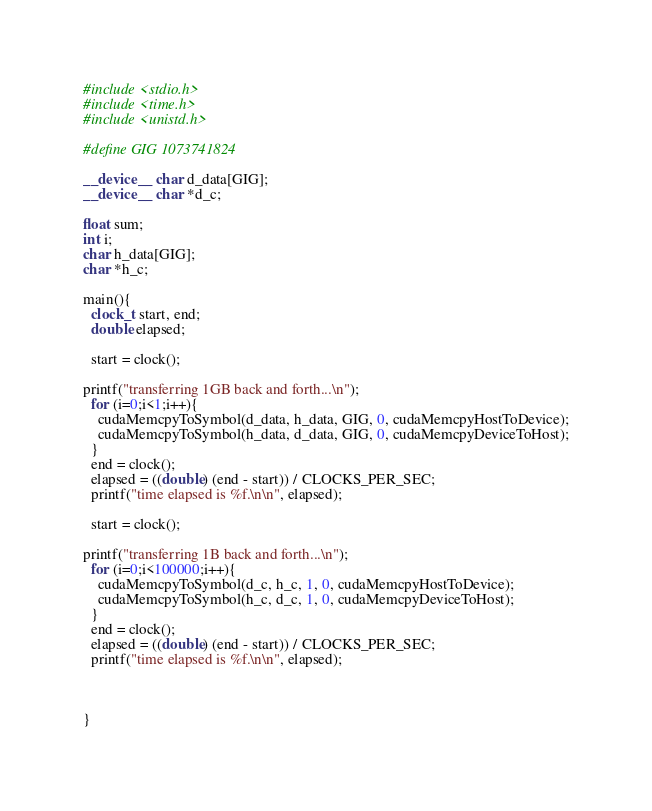<code> <loc_0><loc_0><loc_500><loc_500><_Cuda_>#include <stdio.h>
#include <time.h>
#include <unistd.h>

#define GIG 1073741824

__device__ char d_data[GIG];
__device__ char *d_c;

float sum;
int i;
char h_data[GIG];
char *h_c;

main(){
  clock_t start, end;
  double elapsed;

  start = clock();

printf("transferring 1GB back and forth...\n");
  for (i=0;i<1;i++){
    cudaMemcpyToSymbol(d_data, h_data, GIG, 0, cudaMemcpyHostToDevice);
    cudaMemcpyToSymbol(h_data, d_data, GIG, 0, cudaMemcpyDeviceToHost);
  }
  end = clock();
  elapsed = ((double) (end - start)) / CLOCKS_PER_SEC;
  printf("time elapsed is %f.\n\n", elapsed);

  start = clock();

printf("transferring 1B back and forth...\n");
  for (i=0;i<100000;i++){
    cudaMemcpyToSymbol(d_c, h_c, 1, 0, cudaMemcpyHostToDevice);
    cudaMemcpyToSymbol(h_c, d_c, 1, 0, cudaMemcpyDeviceToHost);
  }
  end = clock();
  elapsed = ((double) (end - start)) / CLOCKS_PER_SEC;
  printf("time elapsed is %f.\n\n", elapsed);

  
  
}
</code> 